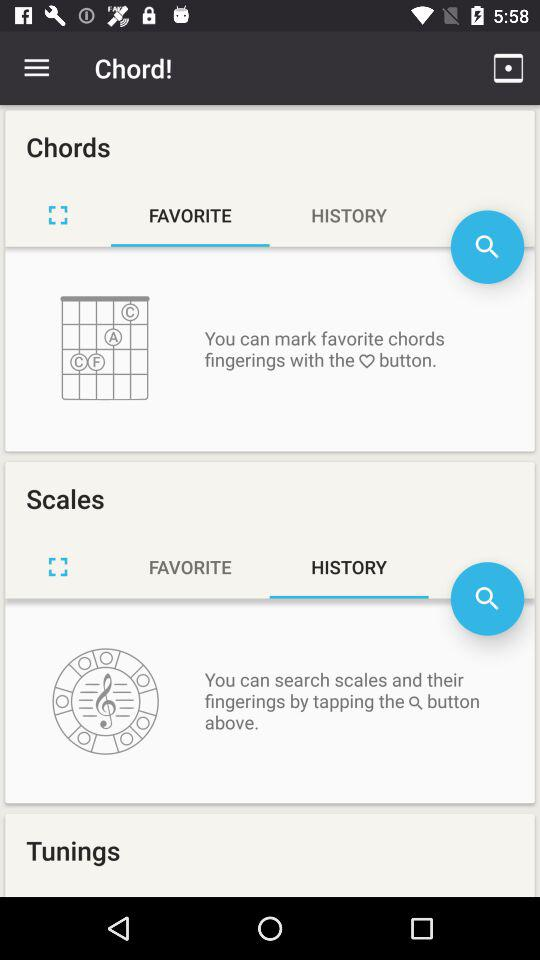What's the selected option in "Chords"? The selected option in "Chords" is "FAVORITE". 